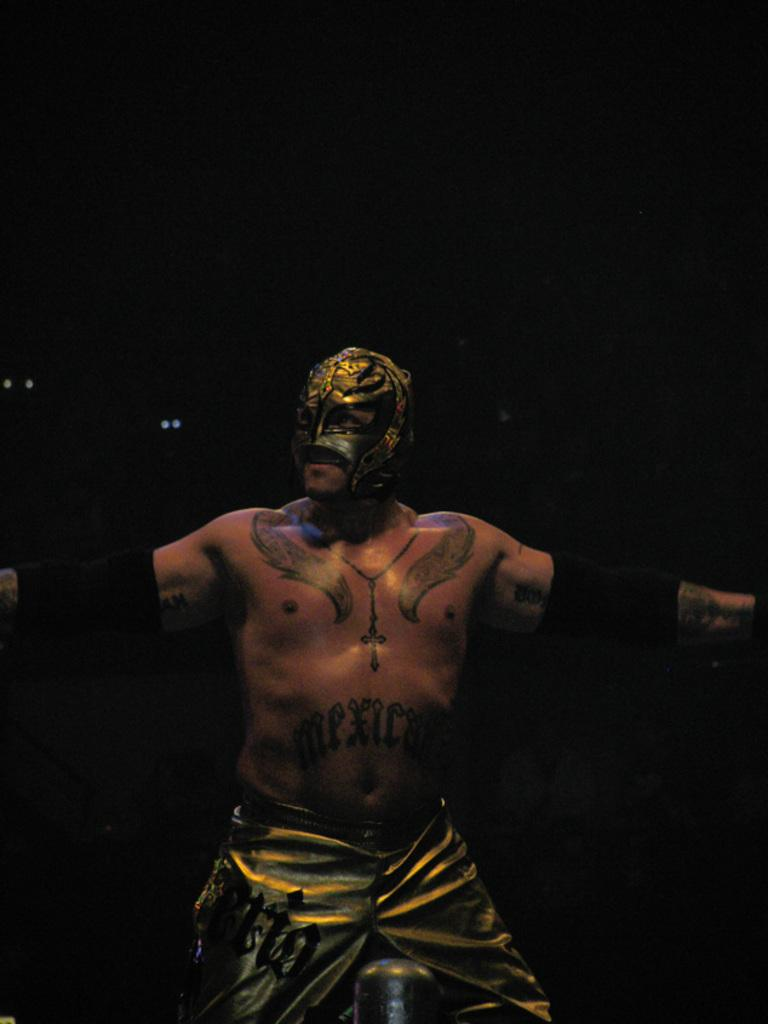What is the main subject of the image? There is a man standing in the image. What is the man wearing on his face? The man is wearing a mask. Can you describe any text visible in the image? Yes, there is text visible in the image. What can be observed on the man's body? The man has tattoos on his body. What color is the background of the image? The background of the image is black. How many cattle are grazing in the plantation behind the man in the image? There is no plantation or cattle present in the image; the background is black. What is the man's wish for the future, as depicted in the image? There is no indication of the man's wishes in the image; it only shows him standing with a mask and tattoos. 